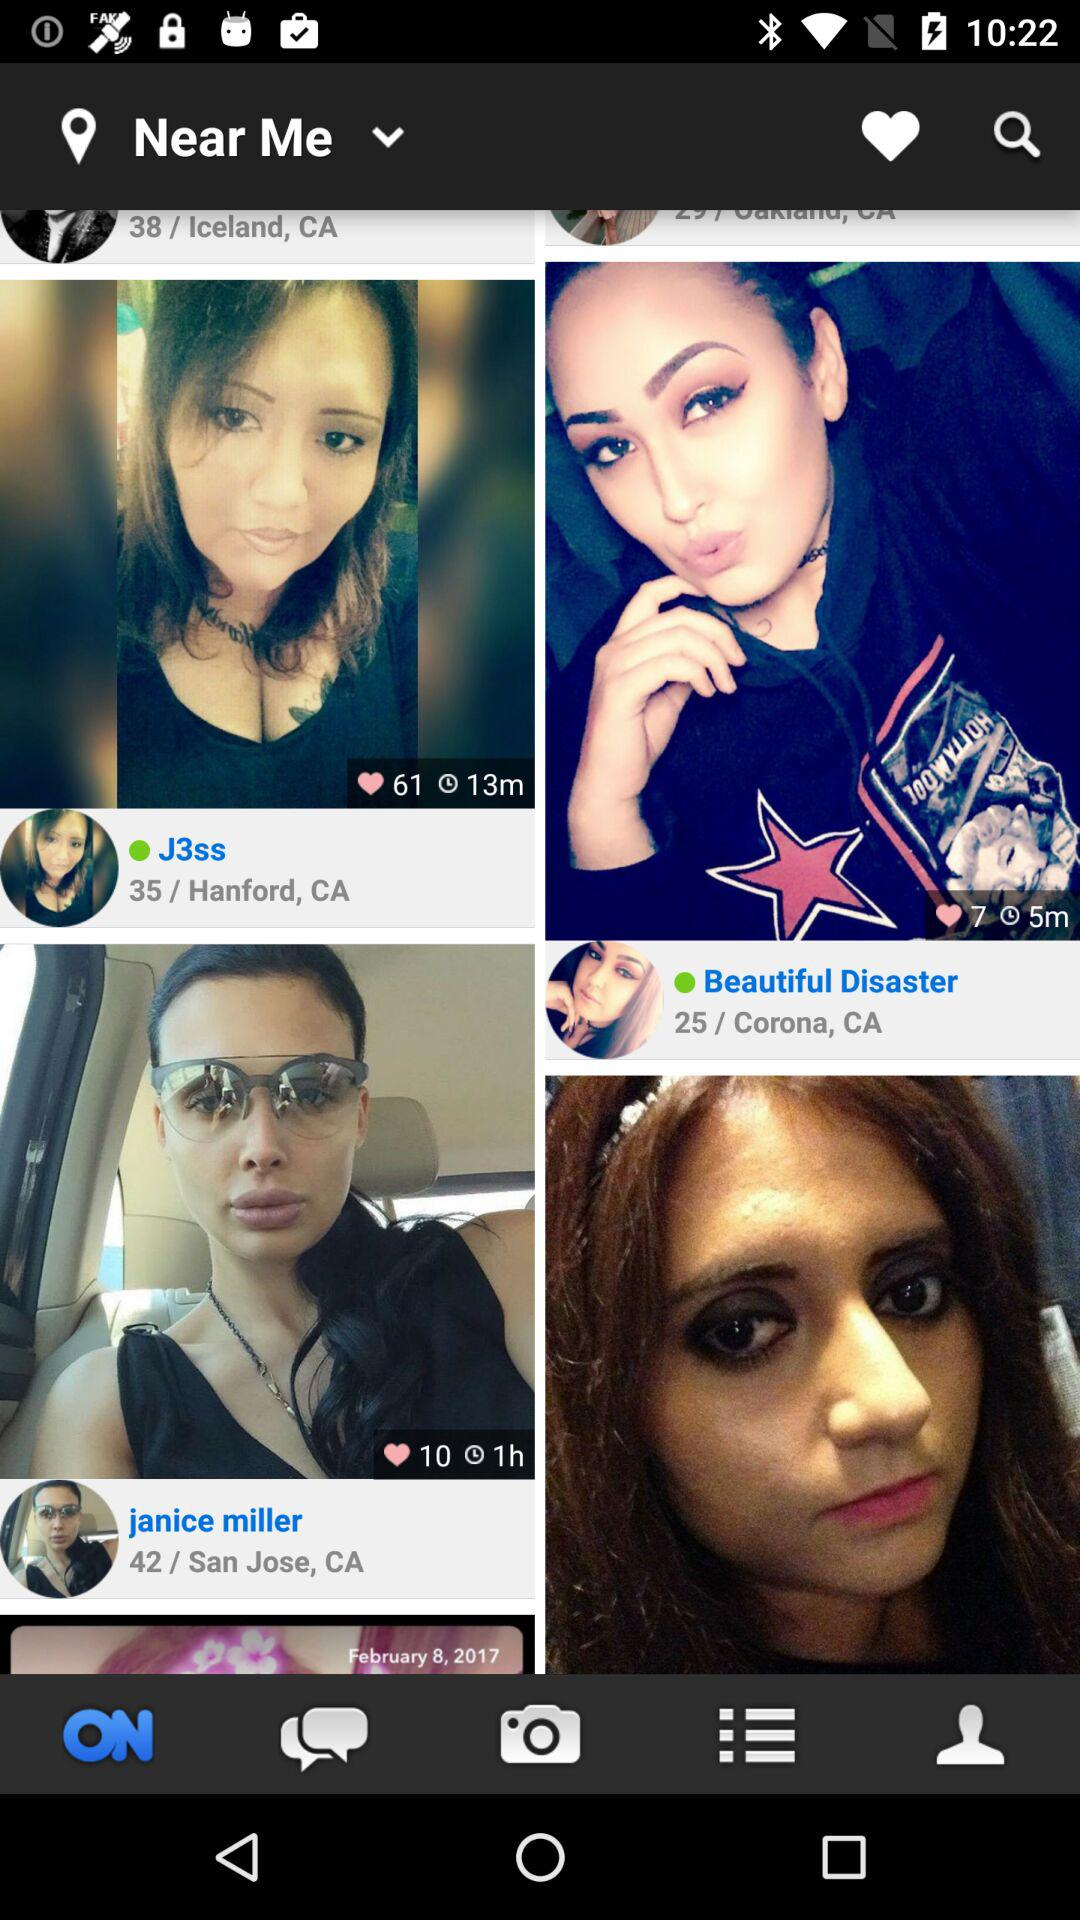Where is "Beautiful Disaster" from? "Beautiful Disaster" is from Corona, CA. 